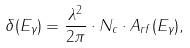<formula> <loc_0><loc_0><loc_500><loc_500>\delta ( E _ { \gamma } ) = \frac { \lambda ^ { 2 } } { 2 \pi } \cdot N _ { c } \cdot A _ { r f } ( E _ { \gamma } ) ,</formula> 